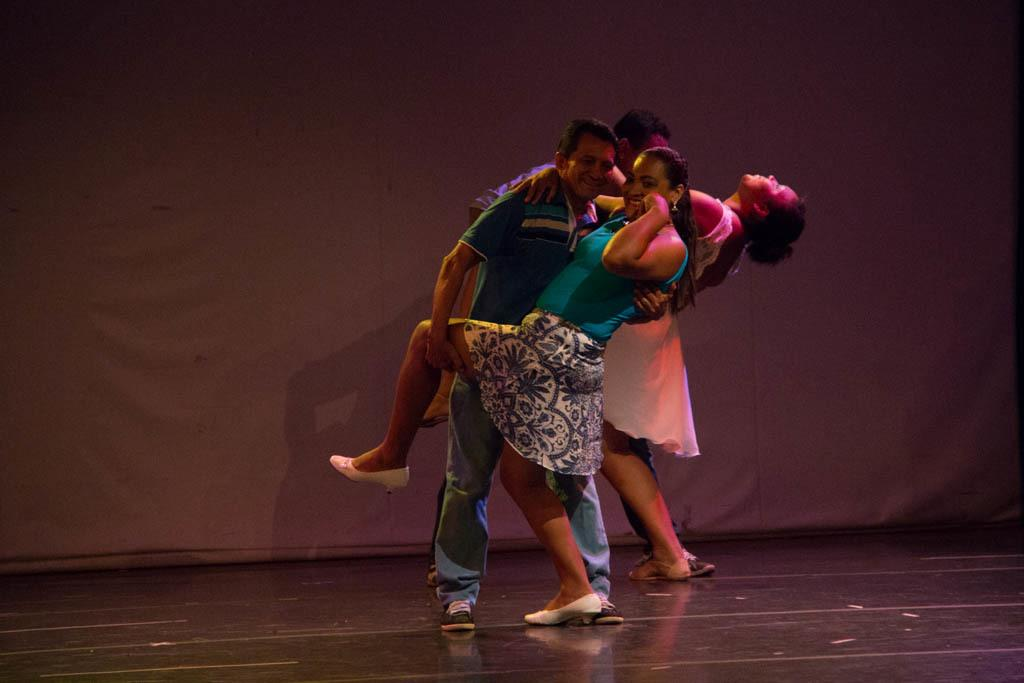What are the persons in the image doing? The persons in the image are dancing. What is the emotional expression of the persons in the image? The persons are smiling. What can be seen in the background of the image? There is a curtain in the background of the image. What is the color of the curtain? The curtain is white in color. What type of record is being played during the afternoon in the image? There is no record or mention of time of day in the image; it simply shows persons dancing and smiling with a white curtain in the background. 